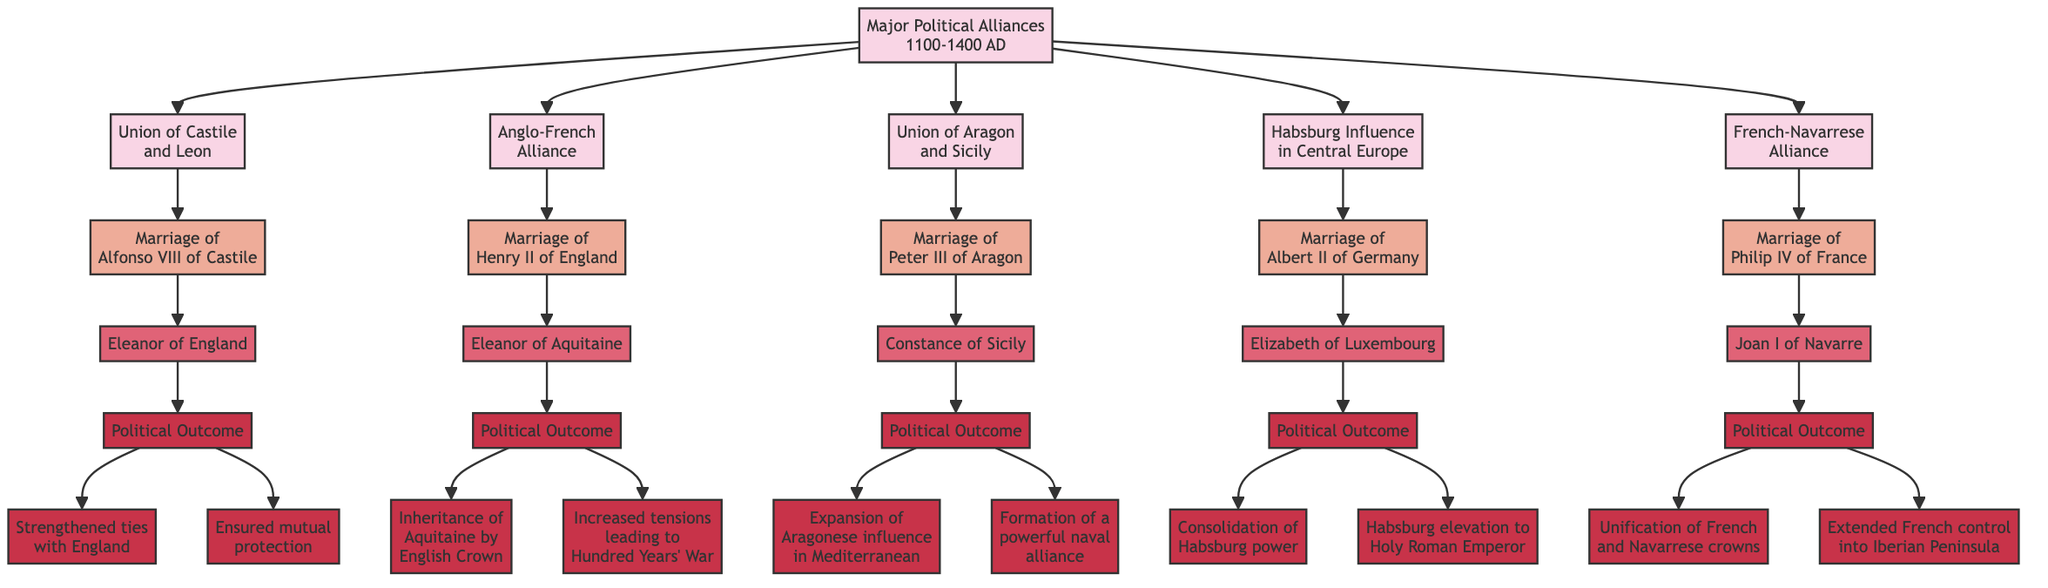What is the first alliance mentioned in the diagram? The diagram starts with the node labeled "Union of Castile and Leon" as the first major political alliance listed.
Answer: Union of Castile and Leon How many major political alliances are displayed in the diagram? There are five alliances outlined in the diagram: Union of Castile and Leon, Anglo-French Alliance, Union of Aragon and Sicily, Habsburg Influence in Central Europe, and French-Navarrese Alliance.
Answer: 5 Who was the spouse of Henry II of England? The spouse of Henry II of England is stated as "Eleanor of Aquitaine" in the diagram, directly connected to the marriage node.
Answer: Eleanor of Aquitaine What was one outcome of the marriage between Alfonso VIII of Castile and Eleanor of England? The diagram indicates two political outcomes, one of which is "Strengthened ties with England," illustrating the benefits of this alliance.
Answer: Strengthened ties with England Which political outcome is associated with the marriage of Philip IV of France? There are two outcomes listed, and one of them is "Unification of French and Navarrese crowns," representing the direct results of this political union.
Answer: Unification of French and Navarrese crowns What significant political event resulted from the marriage of Henry II of England and Eleanor of Aquitaine? The marriage led to "Increased tensions leading to Hundred Years' War," which signifies the long-term impact of this alliance on European conflicts.
Answer: Increased tensions leading to Hundred Years' War What was the outcome of Peter III of Aragon's marriage to Constance of Sicily? The diagram states two outcomes, including "Expansion of Aragonese influence in the Mediterranean," which highlights the territorial significance of the union.
Answer: Expansion of Aragonese influence in the Mediterranean How did Albert II of Germany benefit politically from his marriage? One important outcome from the marriage shown in the diagram is "Habsburg elevation to Holy Roman Emperor," which indicates a significant consolidation of power.
Answer: Habsburg elevation to Holy Roman Emperor What effect did the marriage of Philip IV of France have on the Iberian Peninsula? The diagram reveals that one outcome was "Extended French control into Iberian Peninsula," showcasing the geographic implications of the marriage alliance.
Answer: Extended French control into Iberian Peninsula 